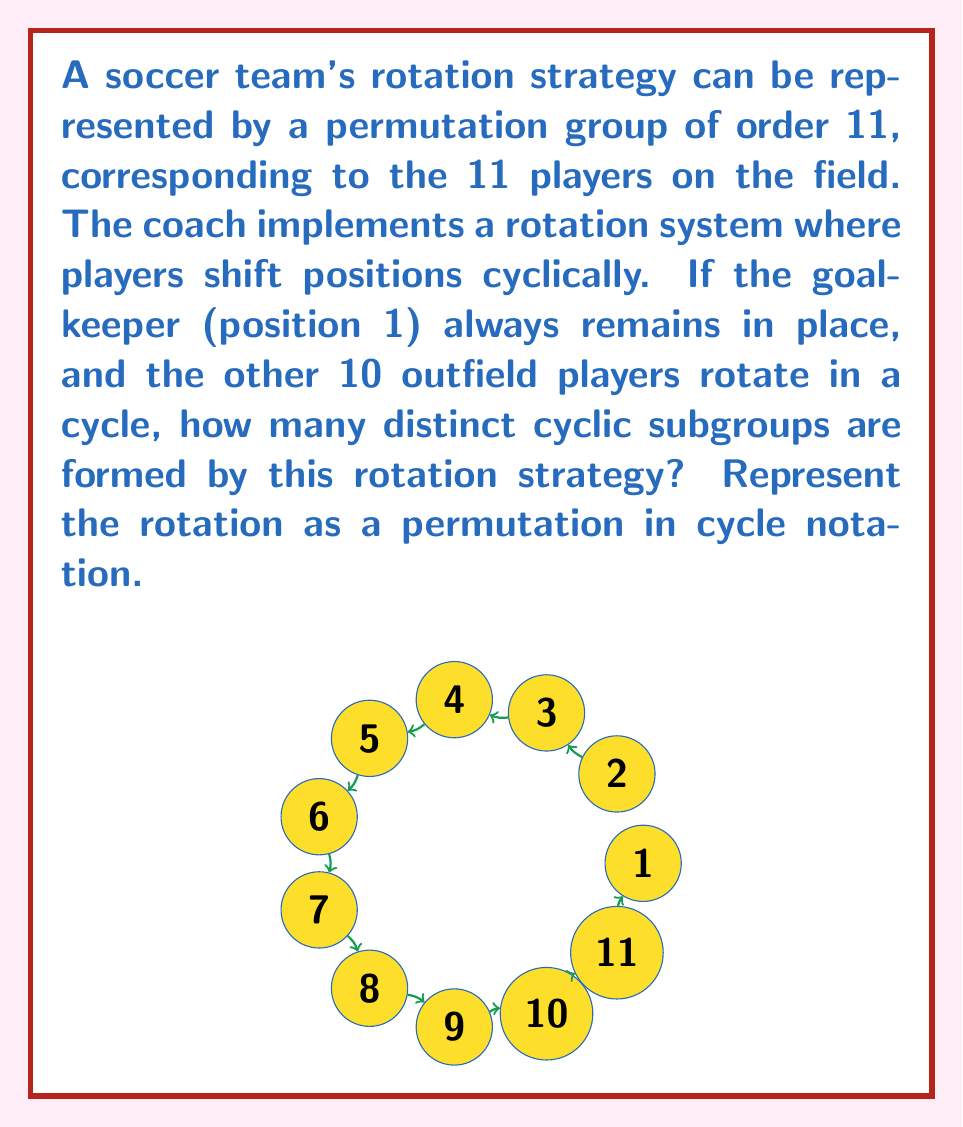Provide a solution to this math problem. Let's approach this step-by-step:

1) First, we need to represent the rotation as a permutation in cycle notation:
   $$(1)(2\,3\,4\,5\,6\,7\,8\,9\,10\,11)$$

   This shows that position 1 (goalkeeper) stays fixed, while the other positions rotate cyclically.

2) To find the number of distinct cyclic subgroups, we need to consider the order of this permutation.

3) The order of a permutation is the least common multiple (LCM) of the lengths of its disjoint cycles.

4) In this case, we have two cycles:
   - A cycle of length 1 (the fixed point)
   - A cycle of length 10

5) The order of the permutation is thus $LCM(1,10) = 10$.

6) In a cyclic group of order $n$, the number of distinct cyclic subgroups is equal to the number of divisors of $n$.

7) The divisors of 10 are: 1, 2, 5, and 10.

Therefore, there are 4 distinct cyclic subgroups formed by this rotation strategy.

These subgroups correspond to:
- The identity permutation (rotating 0 or 10 positions)
- Rotating 5 positions
- Rotating 2 positions
- The full rotation (rotating 1 position)
Answer: 4 cyclic subgroups 